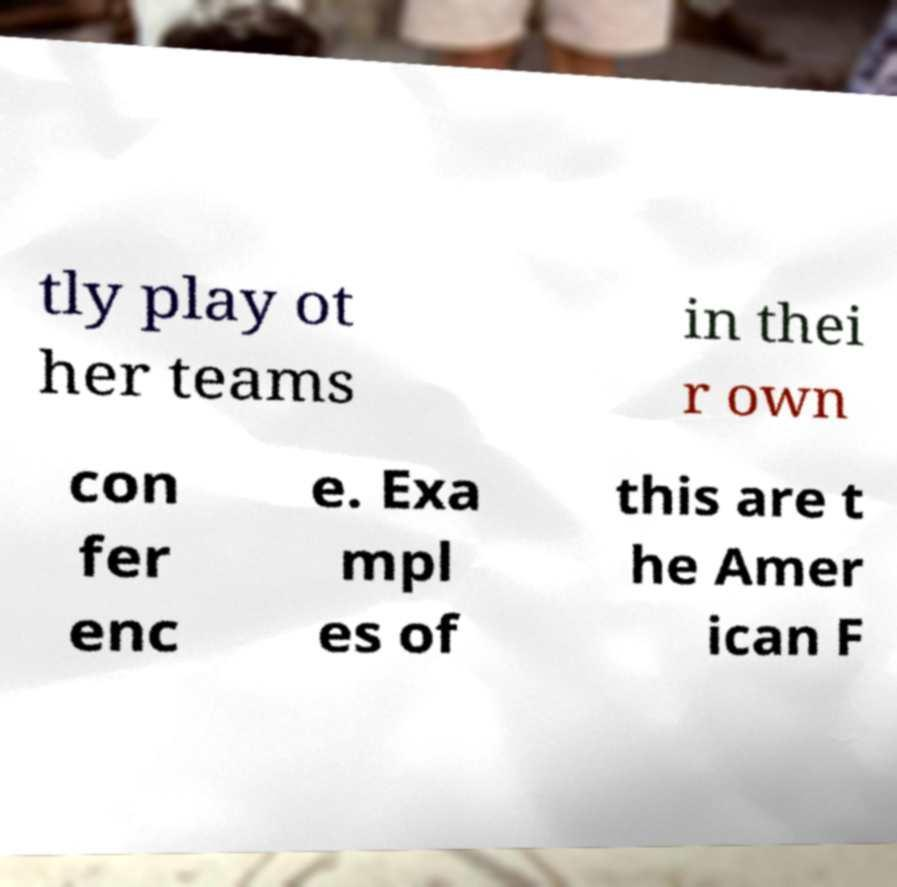There's text embedded in this image that I need extracted. Can you transcribe it verbatim? tly play ot her teams in thei r own con fer enc e. Exa mpl es of this are t he Amer ican F 